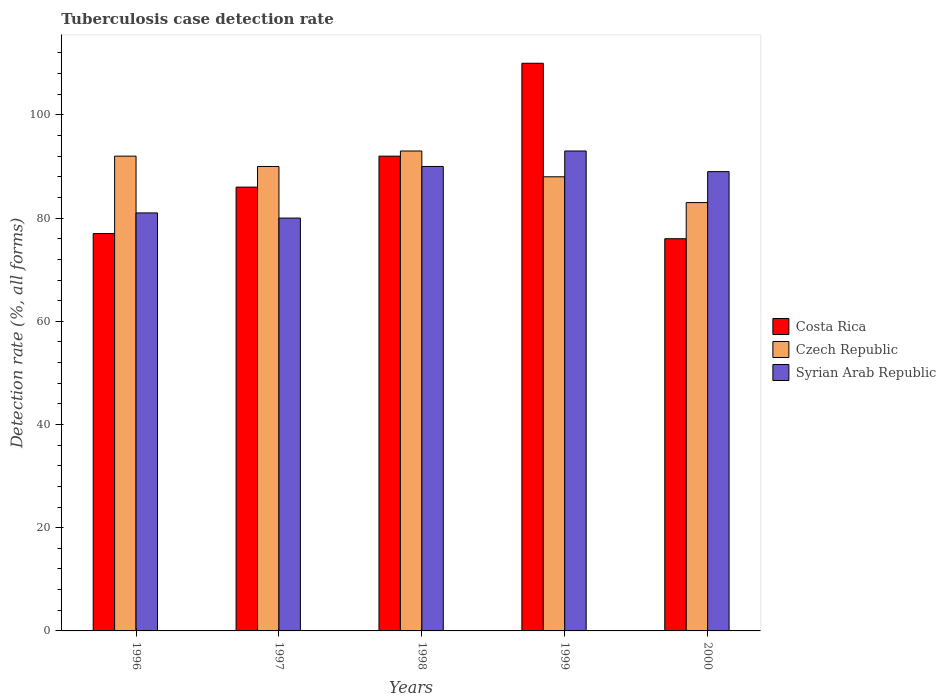How many different coloured bars are there?
Ensure brevity in your answer.  3. How many bars are there on the 4th tick from the left?
Offer a terse response. 3. How many bars are there on the 2nd tick from the right?
Provide a short and direct response. 3. What is the label of the 2nd group of bars from the left?
Your answer should be very brief. 1997. In how many cases, is the number of bars for a given year not equal to the number of legend labels?
Make the answer very short. 0. What is the tuberculosis case detection rate in in Syrian Arab Republic in 1999?
Your response must be concise. 93. Across all years, what is the maximum tuberculosis case detection rate in in Czech Republic?
Your response must be concise. 93. Across all years, what is the minimum tuberculosis case detection rate in in Costa Rica?
Make the answer very short. 76. In which year was the tuberculosis case detection rate in in Costa Rica minimum?
Keep it short and to the point. 2000. What is the total tuberculosis case detection rate in in Costa Rica in the graph?
Provide a succinct answer. 441. What is the difference between the tuberculosis case detection rate in in Costa Rica in 1997 and that in 2000?
Give a very brief answer. 10. What is the difference between the tuberculosis case detection rate in in Czech Republic in 2000 and the tuberculosis case detection rate in in Costa Rica in 1998?
Your response must be concise. -9. What is the average tuberculosis case detection rate in in Syrian Arab Republic per year?
Give a very brief answer. 86.6. In the year 1996, what is the difference between the tuberculosis case detection rate in in Syrian Arab Republic and tuberculosis case detection rate in in Czech Republic?
Ensure brevity in your answer.  -11. What is the ratio of the tuberculosis case detection rate in in Czech Republic in 1996 to that in 1998?
Provide a short and direct response. 0.99. Is the difference between the tuberculosis case detection rate in in Syrian Arab Republic in 1996 and 2000 greater than the difference between the tuberculosis case detection rate in in Czech Republic in 1996 and 2000?
Give a very brief answer. No. In how many years, is the tuberculosis case detection rate in in Syrian Arab Republic greater than the average tuberculosis case detection rate in in Syrian Arab Republic taken over all years?
Your answer should be compact. 3. What does the 1st bar from the right in 1996 represents?
Offer a terse response. Syrian Arab Republic. How many bars are there?
Offer a terse response. 15. Are all the bars in the graph horizontal?
Make the answer very short. No. Are the values on the major ticks of Y-axis written in scientific E-notation?
Provide a short and direct response. No. Does the graph contain any zero values?
Your answer should be very brief. No. Does the graph contain grids?
Provide a short and direct response. No. Where does the legend appear in the graph?
Ensure brevity in your answer.  Center right. How many legend labels are there?
Your response must be concise. 3. What is the title of the graph?
Make the answer very short. Tuberculosis case detection rate. What is the label or title of the X-axis?
Give a very brief answer. Years. What is the label or title of the Y-axis?
Keep it short and to the point. Detection rate (%, all forms). What is the Detection rate (%, all forms) in Czech Republic in 1996?
Your answer should be very brief. 92. What is the Detection rate (%, all forms) in Syrian Arab Republic in 1997?
Keep it short and to the point. 80. What is the Detection rate (%, all forms) in Costa Rica in 1998?
Keep it short and to the point. 92. What is the Detection rate (%, all forms) of Czech Republic in 1998?
Offer a terse response. 93. What is the Detection rate (%, all forms) of Syrian Arab Republic in 1998?
Keep it short and to the point. 90. What is the Detection rate (%, all forms) in Costa Rica in 1999?
Provide a succinct answer. 110. What is the Detection rate (%, all forms) in Czech Republic in 1999?
Your answer should be compact. 88. What is the Detection rate (%, all forms) in Syrian Arab Republic in 1999?
Offer a terse response. 93. What is the Detection rate (%, all forms) in Costa Rica in 2000?
Your answer should be compact. 76. What is the Detection rate (%, all forms) of Czech Republic in 2000?
Make the answer very short. 83. What is the Detection rate (%, all forms) in Syrian Arab Republic in 2000?
Ensure brevity in your answer.  89. Across all years, what is the maximum Detection rate (%, all forms) in Costa Rica?
Offer a very short reply. 110. Across all years, what is the maximum Detection rate (%, all forms) in Czech Republic?
Keep it short and to the point. 93. Across all years, what is the maximum Detection rate (%, all forms) of Syrian Arab Republic?
Offer a terse response. 93. Across all years, what is the minimum Detection rate (%, all forms) in Czech Republic?
Provide a short and direct response. 83. Across all years, what is the minimum Detection rate (%, all forms) of Syrian Arab Republic?
Provide a short and direct response. 80. What is the total Detection rate (%, all forms) in Costa Rica in the graph?
Your answer should be very brief. 441. What is the total Detection rate (%, all forms) in Czech Republic in the graph?
Offer a terse response. 446. What is the total Detection rate (%, all forms) in Syrian Arab Republic in the graph?
Offer a very short reply. 433. What is the difference between the Detection rate (%, all forms) of Costa Rica in 1996 and that in 1997?
Your response must be concise. -9. What is the difference between the Detection rate (%, all forms) of Czech Republic in 1996 and that in 1997?
Make the answer very short. 2. What is the difference between the Detection rate (%, all forms) in Costa Rica in 1996 and that in 1998?
Your response must be concise. -15. What is the difference between the Detection rate (%, all forms) of Syrian Arab Republic in 1996 and that in 1998?
Keep it short and to the point. -9. What is the difference between the Detection rate (%, all forms) in Costa Rica in 1996 and that in 1999?
Keep it short and to the point. -33. What is the difference between the Detection rate (%, all forms) of Czech Republic in 1996 and that in 1999?
Make the answer very short. 4. What is the difference between the Detection rate (%, all forms) of Syrian Arab Republic in 1996 and that in 1999?
Provide a succinct answer. -12. What is the difference between the Detection rate (%, all forms) in Costa Rica in 1997 and that in 1998?
Your answer should be very brief. -6. What is the difference between the Detection rate (%, all forms) in Czech Republic in 1997 and that in 1998?
Provide a short and direct response. -3. What is the difference between the Detection rate (%, all forms) of Costa Rica in 1997 and that in 1999?
Provide a succinct answer. -24. What is the difference between the Detection rate (%, all forms) in Czech Republic in 1997 and that in 1999?
Your answer should be compact. 2. What is the difference between the Detection rate (%, all forms) of Costa Rica in 1997 and that in 2000?
Provide a succinct answer. 10. What is the difference between the Detection rate (%, all forms) of Syrian Arab Republic in 1998 and that in 1999?
Provide a short and direct response. -3. What is the difference between the Detection rate (%, all forms) in Costa Rica in 1998 and that in 2000?
Your answer should be very brief. 16. What is the difference between the Detection rate (%, all forms) of Czech Republic in 1998 and that in 2000?
Your answer should be very brief. 10. What is the difference between the Detection rate (%, all forms) in Costa Rica in 1999 and that in 2000?
Make the answer very short. 34. What is the difference between the Detection rate (%, all forms) of Czech Republic in 1999 and that in 2000?
Ensure brevity in your answer.  5. What is the difference between the Detection rate (%, all forms) in Syrian Arab Republic in 1999 and that in 2000?
Keep it short and to the point. 4. What is the difference between the Detection rate (%, all forms) in Costa Rica in 1996 and the Detection rate (%, all forms) in Syrian Arab Republic in 1997?
Your response must be concise. -3. What is the difference between the Detection rate (%, all forms) in Czech Republic in 1996 and the Detection rate (%, all forms) in Syrian Arab Republic in 1998?
Make the answer very short. 2. What is the difference between the Detection rate (%, all forms) of Costa Rica in 1996 and the Detection rate (%, all forms) of Czech Republic in 1999?
Make the answer very short. -11. What is the difference between the Detection rate (%, all forms) in Czech Republic in 1996 and the Detection rate (%, all forms) in Syrian Arab Republic in 1999?
Provide a succinct answer. -1. What is the difference between the Detection rate (%, all forms) in Costa Rica in 1996 and the Detection rate (%, all forms) in Syrian Arab Republic in 2000?
Make the answer very short. -12. What is the difference between the Detection rate (%, all forms) of Costa Rica in 1997 and the Detection rate (%, all forms) of Czech Republic in 1998?
Your answer should be very brief. -7. What is the difference between the Detection rate (%, all forms) in Czech Republic in 1997 and the Detection rate (%, all forms) in Syrian Arab Republic in 1998?
Your answer should be very brief. 0. What is the difference between the Detection rate (%, all forms) of Costa Rica in 1997 and the Detection rate (%, all forms) of Czech Republic in 1999?
Make the answer very short. -2. What is the difference between the Detection rate (%, all forms) in Costa Rica in 1997 and the Detection rate (%, all forms) in Syrian Arab Republic in 1999?
Keep it short and to the point. -7. What is the difference between the Detection rate (%, all forms) in Czech Republic in 1997 and the Detection rate (%, all forms) in Syrian Arab Republic in 1999?
Make the answer very short. -3. What is the difference between the Detection rate (%, all forms) in Costa Rica in 1997 and the Detection rate (%, all forms) in Czech Republic in 2000?
Your response must be concise. 3. What is the difference between the Detection rate (%, all forms) in Czech Republic in 1997 and the Detection rate (%, all forms) in Syrian Arab Republic in 2000?
Keep it short and to the point. 1. What is the difference between the Detection rate (%, all forms) in Costa Rica in 1998 and the Detection rate (%, all forms) in Czech Republic in 1999?
Provide a short and direct response. 4. What is the difference between the Detection rate (%, all forms) of Czech Republic in 1998 and the Detection rate (%, all forms) of Syrian Arab Republic in 2000?
Your response must be concise. 4. What is the average Detection rate (%, all forms) of Costa Rica per year?
Offer a terse response. 88.2. What is the average Detection rate (%, all forms) in Czech Republic per year?
Your response must be concise. 89.2. What is the average Detection rate (%, all forms) in Syrian Arab Republic per year?
Your answer should be compact. 86.6. In the year 1996, what is the difference between the Detection rate (%, all forms) of Costa Rica and Detection rate (%, all forms) of Syrian Arab Republic?
Your response must be concise. -4. In the year 1996, what is the difference between the Detection rate (%, all forms) in Czech Republic and Detection rate (%, all forms) in Syrian Arab Republic?
Make the answer very short. 11. In the year 1997, what is the difference between the Detection rate (%, all forms) of Costa Rica and Detection rate (%, all forms) of Czech Republic?
Give a very brief answer. -4. In the year 1997, what is the difference between the Detection rate (%, all forms) of Czech Republic and Detection rate (%, all forms) of Syrian Arab Republic?
Your answer should be very brief. 10. In the year 1998, what is the difference between the Detection rate (%, all forms) in Costa Rica and Detection rate (%, all forms) in Czech Republic?
Your answer should be compact. -1. In the year 1999, what is the difference between the Detection rate (%, all forms) in Costa Rica and Detection rate (%, all forms) in Czech Republic?
Give a very brief answer. 22. In the year 1999, what is the difference between the Detection rate (%, all forms) in Czech Republic and Detection rate (%, all forms) in Syrian Arab Republic?
Offer a very short reply. -5. In the year 2000, what is the difference between the Detection rate (%, all forms) in Costa Rica and Detection rate (%, all forms) in Czech Republic?
Offer a very short reply. -7. What is the ratio of the Detection rate (%, all forms) in Costa Rica in 1996 to that in 1997?
Offer a very short reply. 0.9. What is the ratio of the Detection rate (%, all forms) in Czech Republic in 1996 to that in 1997?
Offer a terse response. 1.02. What is the ratio of the Detection rate (%, all forms) in Syrian Arab Republic in 1996 to that in 1997?
Give a very brief answer. 1.01. What is the ratio of the Detection rate (%, all forms) of Costa Rica in 1996 to that in 1998?
Your answer should be very brief. 0.84. What is the ratio of the Detection rate (%, all forms) of Costa Rica in 1996 to that in 1999?
Offer a very short reply. 0.7. What is the ratio of the Detection rate (%, all forms) in Czech Republic in 1996 to that in 1999?
Your answer should be compact. 1.05. What is the ratio of the Detection rate (%, all forms) in Syrian Arab Republic in 1996 to that in 1999?
Offer a terse response. 0.87. What is the ratio of the Detection rate (%, all forms) of Costa Rica in 1996 to that in 2000?
Your answer should be very brief. 1.01. What is the ratio of the Detection rate (%, all forms) in Czech Republic in 1996 to that in 2000?
Your response must be concise. 1.11. What is the ratio of the Detection rate (%, all forms) in Syrian Arab Republic in 1996 to that in 2000?
Keep it short and to the point. 0.91. What is the ratio of the Detection rate (%, all forms) in Costa Rica in 1997 to that in 1998?
Provide a succinct answer. 0.93. What is the ratio of the Detection rate (%, all forms) in Syrian Arab Republic in 1997 to that in 1998?
Give a very brief answer. 0.89. What is the ratio of the Detection rate (%, all forms) in Costa Rica in 1997 to that in 1999?
Ensure brevity in your answer.  0.78. What is the ratio of the Detection rate (%, all forms) in Czech Republic in 1997 to that in 1999?
Offer a terse response. 1.02. What is the ratio of the Detection rate (%, all forms) of Syrian Arab Republic in 1997 to that in 1999?
Provide a short and direct response. 0.86. What is the ratio of the Detection rate (%, all forms) in Costa Rica in 1997 to that in 2000?
Offer a very short reply. 1.13. What is the ratio of the Detection rate (%, all forms) in Czech Republic in 1997 to that in 2000?
Provide a short and direct response. 1.08. What is the ratio of the Detection rate (%, all forms) in Syrian Arab Republic in 1997 to that in 2000?
Provide a succinct answer. 0.9. What is the ratio of the Detection rate (%, all forms) of Costa Rica in 1998 to that in 1999?
Provide a short and direct response. 0.84. What is the ratio of the Detection rate (%, all forms) of Czech Republic in 1998 to that in 1999?
Offer a very short reply. 1.06. What is the ratio of the Detection rate (%, all forms) of Costa Rica in 1998 to that in 2000?
Your response must be concise. 1.21. What is the ratio of the Detection rate (%, all forms) in Czech Republic in 1998 to that in 2000?
Give a very brief answer. 1.12. What is the ratio of the Detection rate (%, all forms) of Syrian Arab Republic in 1998 to that in 2000?
Give a very brief answer. 1.01. What is the ratio of the Detection rate (%, all forms) in Costa Rica in 1999 to that in 2000?
Make the answer very short. 1.45. What is the ratio of the Detection rate (%, all forms) in Czech Republic in 1999 to that in 2000?
Offer a very short reply. 1.06. What is the ratio of the Detection rate (%, all forms) in Syrian Arab Republic in 1999 to that in 2000?
Your response must be concise. 1.04. What is the difference between the highest and the lowest Detection rate (%, all forms) in Costa Rica?
Give a very brief answer. 34. What is the difference between the highest and the lowest Detection rate (%, all forms) in Czech Republic?
Make the answer very short. 10. 